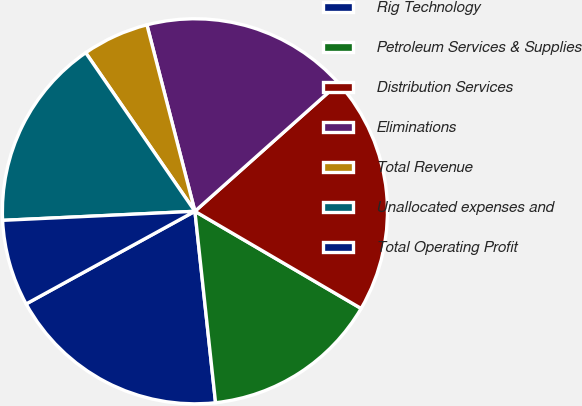<chart> <loc_0><loc_0><loc_500><loc_500><pie_chart><fcel>Rig Technology<fcel>Petroleum Services & Supplies<fcel>Distribution Services<fcel>Eliminations<fcel>Total Revenue<fcel>Unallocated expenses and<fcel>Total Operating Profit<nl><fcel>18.72%<fcel>14.87%<fcel>20.0%<fcel>17.43%<fcel>5.59%<fcel>16.15%<fcel>7.24%<nl></chart> 